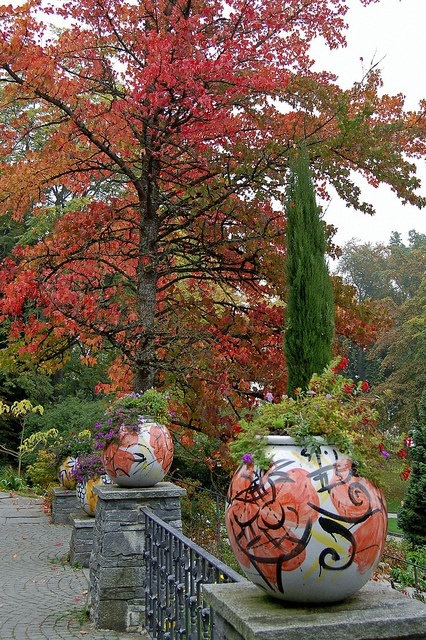Describe the objects in this image and their specific colors. I can see potted plant in white, olive, black, gray, and brown tones, potted plant in white, gray, darkgreen, black, and brown tones, potted plant in white, gray, black, darkgreen, and purple tones, potted plant in white, darkgreen, black, and gray tones, and potted plant in white, gray, black, olive, and darkgray tones in this image. 